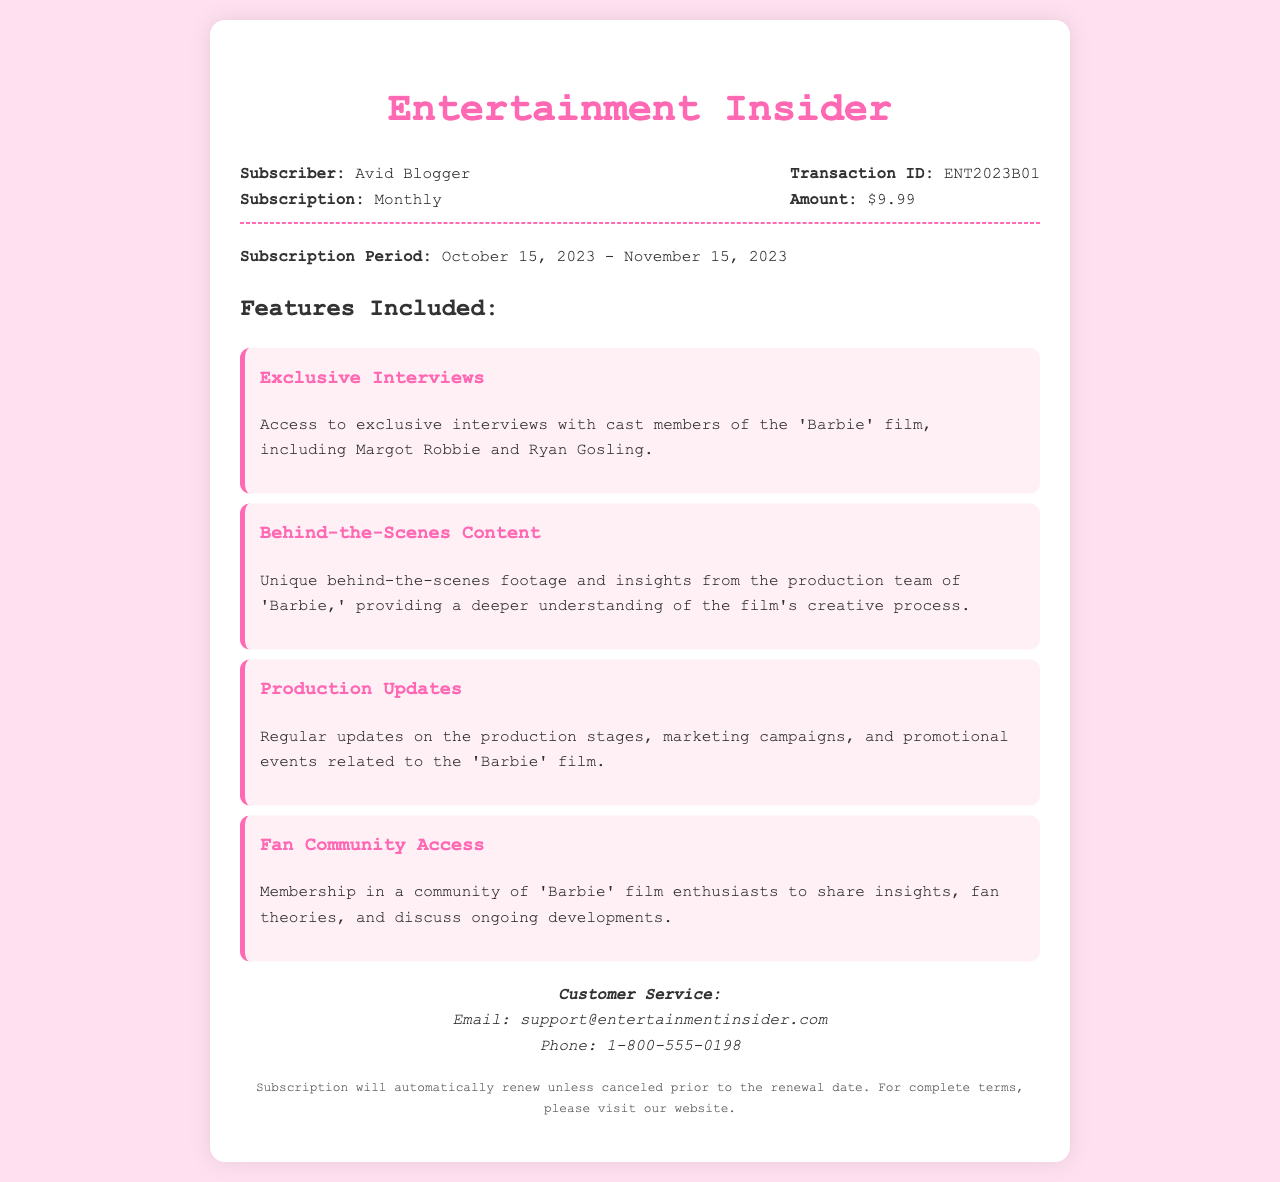What is the subscriber name? The subscriber name is found in the receipt header under "Subscriber."
Answer: Avid Blogger What is the transaction ID? The transaction ID can be found in the receipt header under "Transaction ID."
Answer: ENT2023B01 What is the subscription amount? The subscription amount is listed in the receipt header under "Amount."
Answer: $9.99 What is the subscription period? The subscription period is detailed in the receipt details section.
Answer: October 15, 2023 - November 15, 2023 What is one feature included in the subscription? The features included can be found in the section listing all benefits.
Answer: Exclusive Interviews How many features are listed in the receipt? The total number of features can be counted from the features included section.
Answer: 4 What is the customer service email address? The customer service email address is mentioned in the contact info section.
Answer: support@entertainmentinsider.com What happens if the subscription is not canceled before the renewal date? Information regarding the renewal is provided in the terms section.
Answer: Automatically renew What can subscribers access through the fan community? The fan community section outlines what subscribers can share or discuss.
Answer: Insights, fan theories, and ongoing developments 